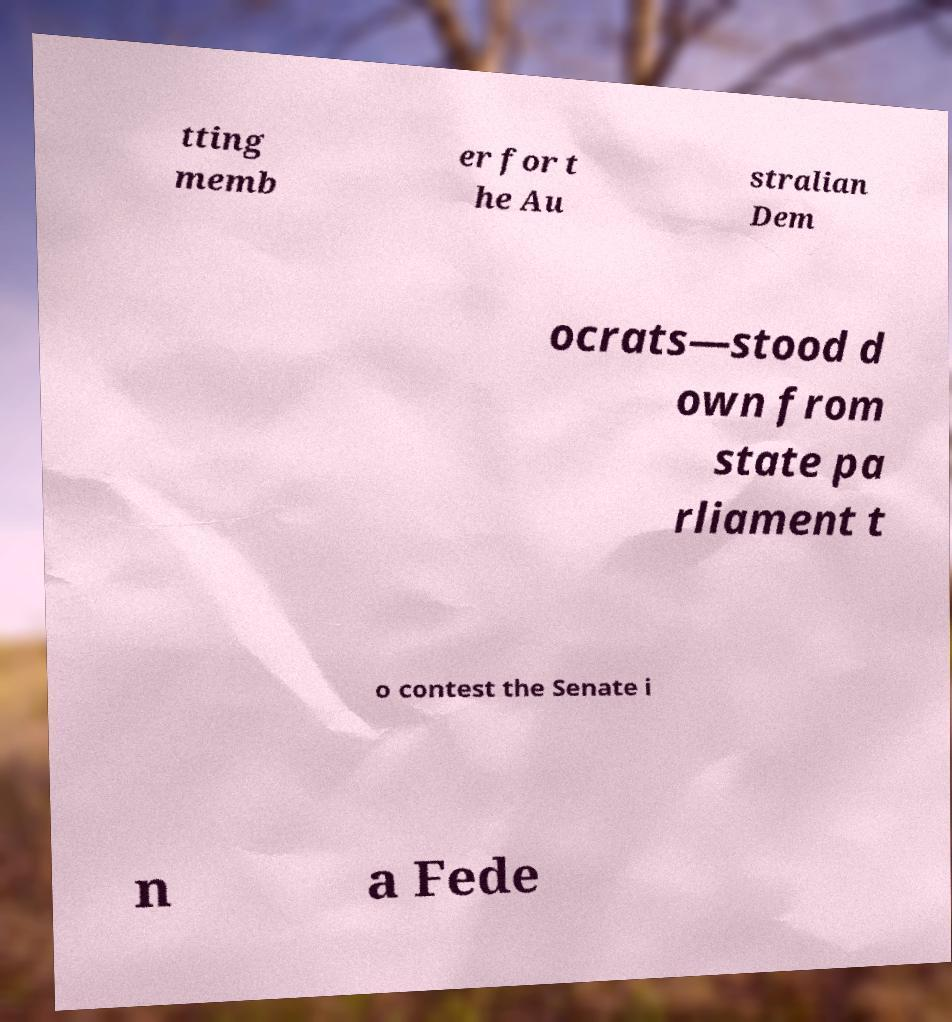Could you extract and type out the text from this image? tting memb er for t he Au stralian Dem ocrats—stood d own from state pa rliament t o contest the Senate i n a Fede 